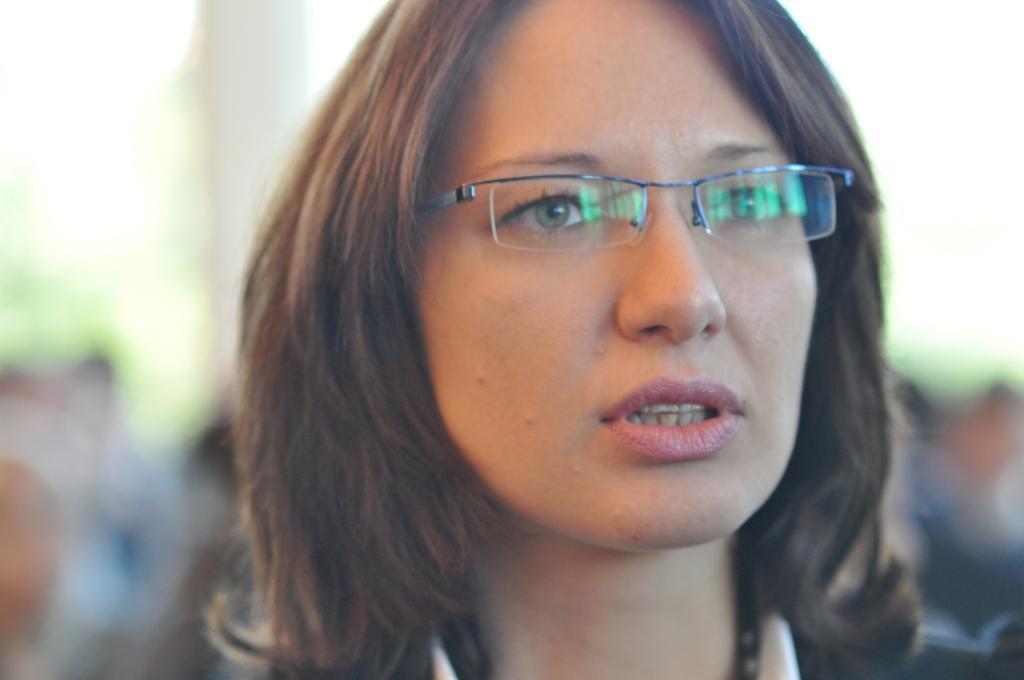Could you give a brief overview of what you see in this image? In this picture there is a woman wearing specs and giving a pose into the camera. Behind there is a blur background. 